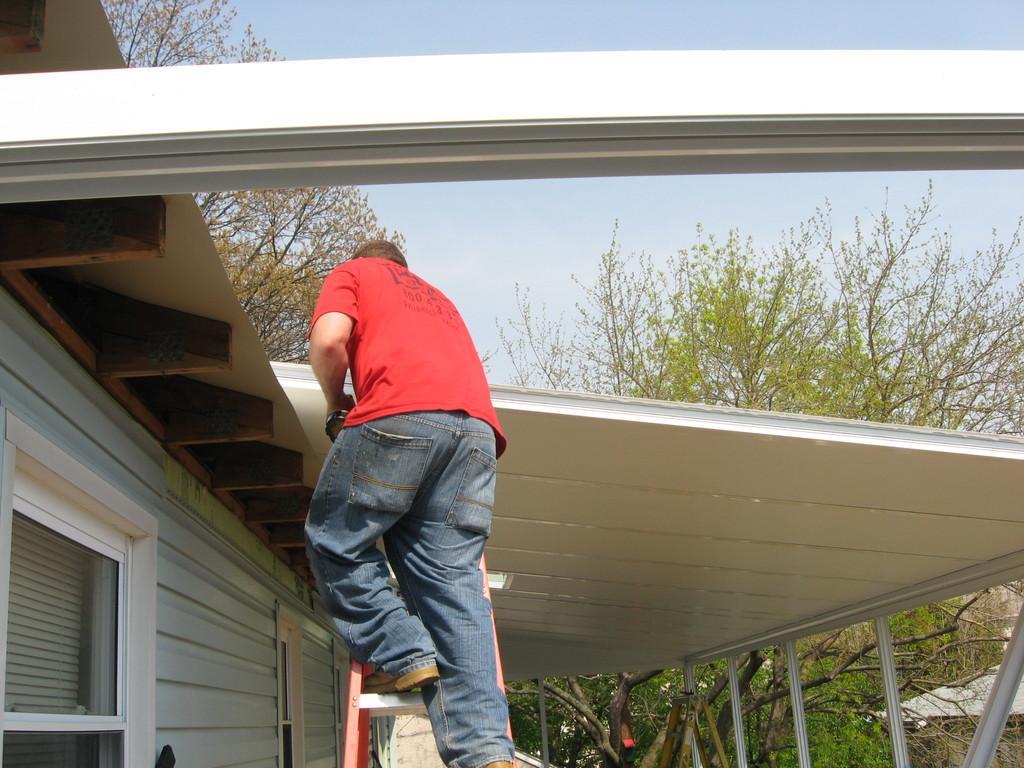Can you describe this image briefly? In this picture we can see a man wearing red color t-shirt and climbing the ladder. Above there is a white roof top. In the background we can see some trees. 